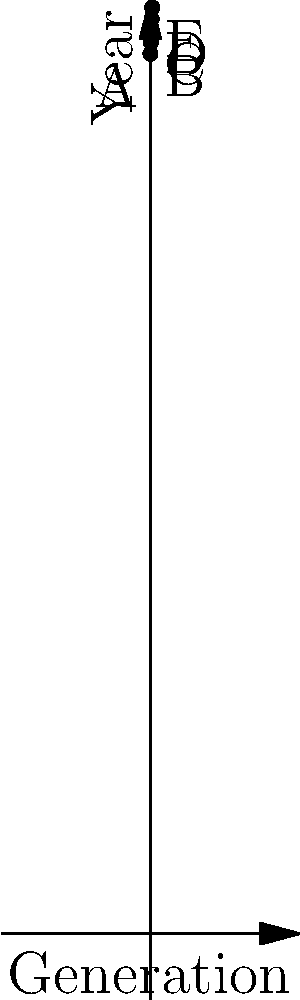In your family tree research, you've plotted the birth years of direct ancestors across generations on a coordinate system. The x-axis represents generations (0 being the earliest), and the y-axis represents birth years. Given the points A(0, 1900), B(1, 1925), C(2, 1950), D(3, 1975), and E(4, 2000), calculate the average slope of this family lineage. What does this slope represent in the context of Romanian family history? To solve this problem, let's follow these steps:

1) The slope between two points is calculated using the formula:
   $m = \frac{y_2 - y_1}{x_2 - x_1}$

2) We can calculate the slope between each consecutive pair of points:

   AB: $m_{AB} = \frac{1925 - 1900}{1 - 0} = 25$
   BC: $m_{BC} = \frac{1950 - 1925}{2 - 1} = 25$
   CD: $m_{CD} = \frac{1975 - 1950}{3 - 2} = 25$
   DE: $m_{DE} = \frac{2000 - 1975}{4 - 3} = 25$

3) We can see that the slope is consistent between all pairs of points, which means the line is straight and the average slope will be the same as any individual slope.

4) Therefore, the average slope is 25.

In the context of Romanian family history, this slope represents the average number of years between generations in this lineage. A slope of 25 means that, on average, each generation in this family had children at the age of 25.

This information can be valuable for genealogists studying Romanian families, as it provides insight into family planning patterns and socio-economic factors that might have influenced when people typically started families in Romania during the 20th century.
Answer: 25 years per generation 